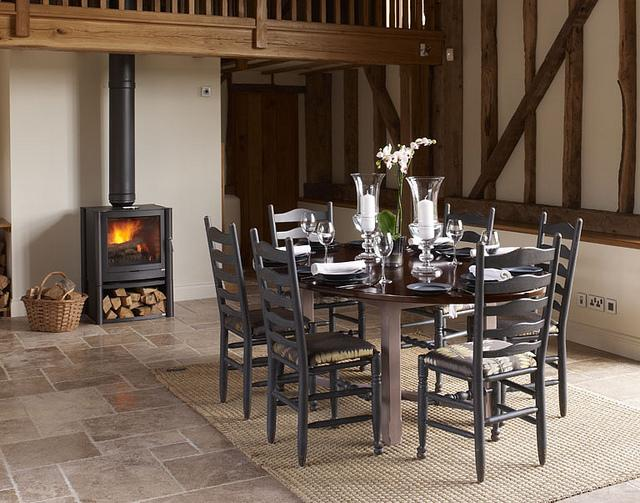What plants help heat this space? trees 